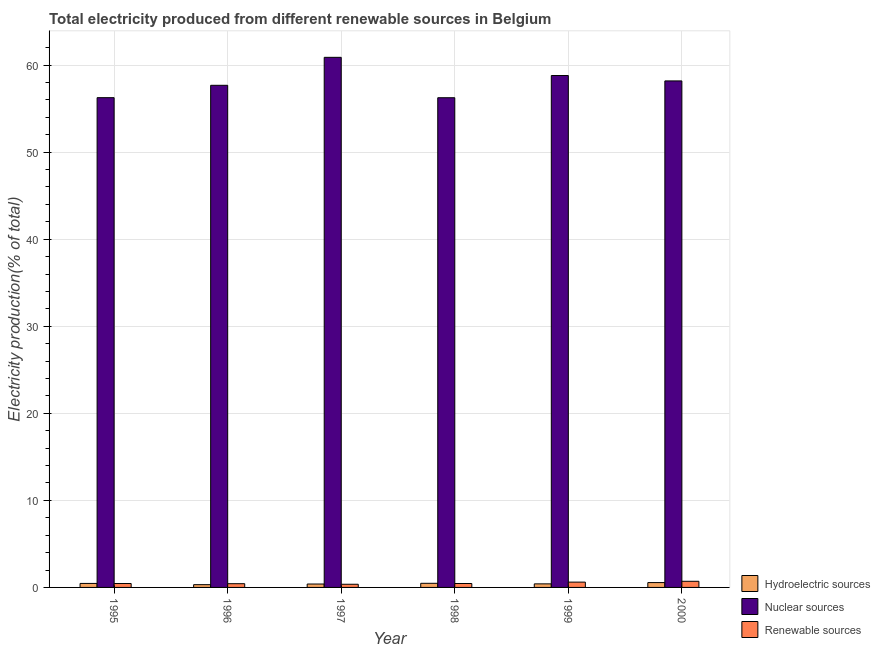How many bars are there on the 4th tick from the left?
Keep it short and to the point. 3. How many bars are there on the 4th tick from the right?
Make the answer very short. 3. In how many cases, is the number of bars for a given year not equal to the number of legend labels?
Provide a short and direct response. 0. What is the percentage of electricity produced by renewable sources in 1997?
Your answer should be very brief. 0.36. Across all years, what is the maximum percentage of electricity produced by hydroelectric sources?
Make the answer very short. 0.56. Across all years, what is the minimum percentage of electricity produced by renewable sources?
Provide a short and direct response. 0.36. In which year was the percentage of electricity produced by nuclear sources maximum?
Make the answer very short. 1997. What is the total percentage of electricity produced by hydroelectric sources in the graph?
Your answer should be very brief. 2.61. What is the difference between the percentage of electricity produced by nuclear sources in 1998 and that in 1999?
Make the answer very short. -2.55. What is the difference between the percentage of electricity produced by nuclear sources in 1997 and the percentage of electricity produced by hydroelectric sources in 1995?
Make the answer very short. 4.63. What is the average percentage of electricity produced by nuclear sources per year?
Give a very brief answer. 58.01. In the year 1997, what is the difference between the percentage of electricity produced by nuclear sources and percentage of electricity produced by hydroelectric sources?
Make the answer very short. 0. What is the ratio of the percentage of electricity produced by renewable sources in 1995 to that in 1999?
Offer a terse response. 0.74. Is the percentage of electricity produced by hydroelectric sources in 1996 less than that in 1997?
Make the answer very short. Yes. What is the difference between the highest and the second highest percentage of electricity produced by nuclear sources?
Provide a short and direct response. 2.09. What is the difference between the highest and the lowest percentage of electricity produced by hydroelectric sources?
Your answer should be very brief. 0.24. Is the sum of the percentage of electricity produced by renewable sources in 1995 and 1997 greater than the maximum percentage of electricity produced by nuclear sources across all years?
Ensure brevity in your answer.  Yes. What does the 3rd bar from the left in 1998 represents?
Offer a terse response. Renewable sources. What does the 2nd bar from the right in 2000 represents?
Your response must be concise. Nuclear sources. Is it the case that in every year, the sum of the percentage of electricity produced by hydroelectric sources and percentage of electricity produced by nuclear sources is greater than the percentage of electricity produced by renewable sources?
Make the answer very short. Yes. How many bars are there?
Offer a very short reply. 18. Are the values on the major ticks of Y-axis written in scientific E-notation?
Offer a terse response. No. Does the graph contain any zero values?
Your response must be concise. No. Does the graph contain grids?
Provide a succinct answer. Yes. Where does the legend appear in the graph?
Offer a terse response. Bottom right. How many legend labels are there?
Keep it short and to the point. 3. What is the title of the graph?
Give a very brief answer. Total electricity produced from different renewable sources in Belgium. Does "Renewable sources" appear as one of the legend labels in the graph?
Your answer should be very brief. Yes. What is the label or title of the X-axis?
Make the answer very short. Year. What is the label or title of the Y-axis?
Your response must be concise. Electricity production(% of total). What is the Electricity production(% of total) in Hydroelectric sources in 1995?
Provide a succinct answer. 0.46. What is the Electricity production(% of total) in Nuclear sources in 1995?
Offer a terse response. 56.25. What is the Electricity production(% of total) of Renewable sources in 1995?
Offer a very short reply. 0.45. What is the Electricity production(% of total) of Hydroelectric sources in 1996?
Offer a very short reply. 0.32. What is the Electricity production(% of total) of Nuclear sources in 1996?
Ensure brevity in your answer.  57.68. What is the Electricity production(% of total) of Renewable sources in 1996?
Provide a succinct answer. 0.43. What is the Electricity production(% of total) of Hydroelectric sources in 1997?
Provide a short and direct response. 0.39. What is the Electricity production(% of total) of Nuclear sources in 1997?
Give a very brief answer. 60.89. What is the Electricity production(% of total) of Renewable sources in 1997?
Provide a succinct answer. 0.36. What is the Electricity production(% of total) in Hydroelectric sources in 1998?
Keep it short and to the point. 0.47. What is the Electricity production(% of total) of Nuclear sources in 1998?
Provide a short and direct response. 56.25. What is the Electricity production(% of total) in Renewable sources in 1998?
Give a very brief answer. 0.45. What is the Electricity production(% of total) in Hydroelectric sources in 1999?
Your answer should be very brief. 0.41. What is the Electricity production(% of total) in Nuclear sources in 1999?
Your answer should be compact. 58.8. What is the Electricity production(% of total) of Renewable sources in 1999?
Offer a terse response. 0.61. What is the Electricity production(% of total) in Hydroelectric sources in 2000?
Give a very brief answer. 0.56. What is the Electricity production(% of total) in Nuclear sources in 2000?
Your response must be concise. 58.18. What is the Electricity production(% of total) of Renewable sources in 2000?
Offer a very short reply. 0.71. Across all years, what is the maximum Electricity production(% of total) of Hydroelectric sources?
Keep it short and to the point. 0.56. Across all years, what is the maximum Electricity production(% of total) of Nuclear sources?
Your response must be concise. 60.89. Across all years, what is the maximum Electricity production(% of total) in Renewable sources?
Make the answer very short. 0.71. Across all years, what is the minimum Electricity production(% of total) of Hydroelectric sources?
Provide a succinct answer. 0.32. Across all years, what is the minimum Electricity production(% of total) of Nuclear sources?
Provide a succinct answer. 56.25. Across all years, what is the minimum Electricity production(% of total) in Renewable sources?
Keep it short and to the point. 0.36. What is the total Electricity production(% of total) in Hydroelectric sources in the graph?
Offer a terse response. 2.61. What is the total Electricity production(% of total) in Nuclear sources in the graph?
Keep it short and to the point. 348.04. What is the total Electricity production(% of total) in Renewable sources in the graph?
Your answer should be very brief. 3.01. What is the difference between the Electricity production(% of total) in Hydroelectric sources in 1995 and that in 1996?
Your answer should be very brief. 0.14. What is the difference between the Electricity production(% of total) in Nuclear sources in 1995 and that in 1996?
Make the answer very short. -1.42. What is the difference between the Electricity production(% of total) in Renewable sources in 1995 and that in 1996?
Ensure brevity in your answer.  0.02. What is the difference between the Electricity production(% of total) in Hydroelectric sources in 1995 and that in 1997?
Provide a succinct answer. 0.07. What is the difference between the Electricity production(% of total) of Nuclear sources in 1995 and that in 1997?
Your answer should be very brief. -4.63. What is the difference between the Electricity production(% of total) in Renewable sources in 1995 and that in 1997?
Your answer should be very brief. 0.09. What is the difference between the Electricity production(% of total) of Hydroelectric sources in 1995 and that in 1998?
Offer a very short reply. -0.01. What is the difference between the Electricity production(% of total) of Nuclear sources in 1995 and that in 1998?
Make the answer very short. 0.01. What is the difference between the Electricity production(% of total) of Renewable sources in 1995 and that in 1998?
Give a very brief answer. -0. What is the difference between the Electricity production(% of total) of Hydroelectric sources in 1995 and that in 1999?
Offer a terse response. 0.05. What is the difference between the Electricity production(% of total) of Nuclear sources in 1995 and that in 1999?
Give a very brief answer. -2.54. What is the difference between the Electricity production(% of total) of Renewable sources in 1995 and that in 1999?
Provide a short and direct response. -0.16. What is the difference between the Electricity production(% of total) in Hydroelectric sources in 1995 and that in 2000?
Give a very brief answer. -0.1. What is the difference between the Electricity production(% of total) of Nuclear sources in 1995 and that in 2000?
Offer a terse response. -1.93. What is the difference between the Electricity production(% of total) in Renewable sources in 1995 and that in 2000?
Provide a succinct answer. -0.26. What is the difference between the Electricity production(% of total) of Hydroelectric sources in 1996 and that in 1997?
Offer a very short reply. -0.07. What is the difference between the Electricity production(% of total) of Nuclear sources in 1996 and that in 1997?
Make the answer very short. -3.21. What is the difference between the Electricity production(% of total) of Renewable sources in 1996 and that in 1997?
Give a very brief answer. 0.07. What is the difference between the Electricity production(% of total) of Hydroelectric sources in 1996 and that in 1998?
Your response must be concise. -0.16. What is the difference between the Electricity production(% of total) of Nuclear sources in 1996 and that in 1998?
Offer a very short reply. 1.43. What is the difference between the Electricity production(% of total) of Renewable sources in 1996 and that in 1998?
Your answer should be very brief. -0.02. What is the difference between the Electricity production(% of total) in Hydroelectric sources in 1996 and that in 1999?
Offer a very short reply. -0.09. What is the difference between the Electricity production(% of total) of Nuclear sources in 1996 and that in 1999?
Your answer should be compact. -1.12. What is the difference between the Electricity production(% of total) in Renewable sources in 1996 and that in 1999?
Keep it short and to the point. -0.18. What is the difference between the Electricity production(% of total) in Hydroelectric sources in 1996 and that in 2000?
Your answer should be compact. -0.24. What is the difference between the Electricity production(% of total) in Nuclear sources in 1996 and that in 2000?
Ensure brevity in your answer.  -0.5. What is the difference between the Electricity production(% of total) in Renewable sources in 1996 and that in 2000?
Provide a succinct answer. -0.28. What is the difference between the Electricity production(% of total) of Hydroelectric sources in 1997 and that in 1998?
Provide a short and direct response. -0.08. What is the difference between the Electricity production(% of total) of Nuclear sources in 1997 and that in 1998?
Offer a very short reply. 4.64. What is the difference between the Electricity production(% of total) of Renewable sources in 1997 and that in 1998?
Offer a very short reply. -0.09. What is the difference between the Electricity production(% of total) of Hydroelectric sources in 1997 and that in 1999?
Offer a very short reply. -0.02. What is the difference between the Electricity production(% of total) of Nuclear sources in 1997 and that in 1999?
Your response must be concise. 2.09. What is the difference between the Electricity production(% of total) of Renewable sources in 1997 and that in 1999?
Provide a succinct answer. -0.25. What is the difference between the Electricity production(% of total) of Hydroelectric sources in 1997 and that in 2000?
Offer a very short reply. -0.16. What is the difference between the Electricity production(% of total) in Nuclear sources in 1997 and that in 2000?
Ensure brevity in your answer.  2.71. What is the difference between the Electricity production(% of total) in Renewable sources in 1997 and that in 2000?
Your answer should be compact. -0.34. What is the difference between the Electricity production(% of total) in Hydroelectric sources in 1998 and that in 1999?
Provide a short and direct response. 0.06. What is the difference between the Electricity production(% of total) in Nuclear sources in 1998 and that in 1999?
Provide a short and direct response. -2.55. What is the difference between the Electricity production(% of total) in Renewable sources in 1998 and that in 1999?
Ensure brevity in your answer.  -0.16. What is the difference between the Electricity production(% of total) of Hydroelectric sources in 1998 and that in 2000?
Your answer should be very brief. -0.08. What is the difference between the Electricity production(% of total) of Nuclear sources in 1998 and that in 2000?
Your response must be concise. -1.93. What is the difference between the Electricity production(% of total) in Renewable sources in 1998 and that in 2000?
Provide a succinct answer. -0.25. What is the difference between the Electricity production(% of total) in Hydroelectric sources in 1999 and that in 2000?
Your answer should be very brief. -0.15. What is the difference between the Electricity production(% of total) of Nuclear sources in 1999 and that in 2000?
Offer a terse response. 0.62. What is the difference between the Electricity production(% of total) in Renewable sources in 1999 and that in 2000?
Provide a succinct answer. -0.1. What is the difference between the Electricity production(% of total) in Hydroelectric sources in 1995 and the Electricity production(% of total) in Nuclear sources in 1996?
Offer a terse response. -57.22. What is the difference between the Electricity production(% of total) of Hydroelectric sources in 1995 and the Electricity production(% of total) of Renewable sources in 1996?
Your response must be concise. 0.03. What is the difference between the Electricity production(% of total) in Nuclear sources in 1995 and the Electricity production(% of total) in Renewable sources in 1996?
Make the answer very short. 55.83. What is the difference between the Electricity production(% of total) of Hydroelectric sources in 1995 and the Electricity production(% of total) of Nuclear sources in 1997?
Provide a succinct answer. -60.43. What is the difference between the Electricity production(% of total) of Hydroelectric sources in 1995 and the Electricity production(% of total) of Renewable sources in 1997?
Give a very brief answer. 0.1. What is the difference between the Electricity production(% of total) of Nuclear sources in 1995 and the Electricity production(% of total) of Renewable sources in 1997?
Offer a terse response. 55.89. What is the difference between the Electricity production(% of total) of Hydroelectric sources in 1995 and the Electricity production(% of total) of Nuclear sources in 1998?
Your answer should be very brief. -55.79. What is the difference between the Electricity production(% of total) of Hydroelectric sources in 1995 and the Electricity production(% of total) of Renewable sources in 1998?
Provide a short and direct response. 0.01. What is the difference between the Electricity production(% of total) of Nuclear sources in 1995 and the Electricity production(% of total) of Renewable sources in 1998?
Keep it short and to the point. 55.8. What is the difference between the Electricity production(% of total) of Hydroelectric sources in 1995 and the Electricity production(% of total) of Nuclear sources in 1999?
Your response must be concise. -58.34. What is the difference between the Electricity production(% of total) of Hydroelectric sources in 1995 and the Electricity production(% of total) of Renewable sources in 1999?
Your response must be concise. -0.15. What is the difference between the Electricity production(% of total) in Nuclear sources in 1995 and the Electricity production(% of total) in Renewable sources in 1999?
Ensure brevity in your answer.  55.64. What is the difference between the Electricity production(% of total) in Hydroelectric sources in 1995 and the Electricity production(% of total) in Nuclear sources in 2000?
Your answer should be very brief. -57.72. What is the difference between the Electricity production(% of total) of Hydroelectric sources in 1995 and the Electricity production(% of total) of Renewable sources in 2000?
Give a very brief answer. -0.25. What is the difference between the Electricity production(% of total) of Nuclear sources in 1995 and the Electricity production(% of total) of Renewable sources in 2000?
Offer a very short reply. 55.55. What is the difference between the Electricity production(% of total) in Hydroelectric sources in 1996 and the Electricity production(% of total) in Nuclear sources in 1997?
Give a very brief answer. -60.57. What is the difference between the Electricity production(% of total) of Hydroelectric sources in 1996 and the Electricity production(% of total) of Renewable sources in 1997?
Your response must be concise. -0.05. What is the difference between the Electricity production(% of total) in Nuclear sources in 1996 and the Electricity production(% of total) in Renewable sources in 1997?
Your answer should be very brief. 57.31. What is the difference between the Electricity production(% of total) of Hydroelectric sources in 1996 and the Electricity production(% of total) of Nuclear sources in 1998?
Your answer should be compact. -55.93. What is the difference between the Electricity production(% of total) in Hydroelectric sources in 1996 and the Electricity production(% of total) in Renewable sources in 1998?
Make the answer very short. -0.13. What is the difference between the Electricity production(% of total) in Nuclear sources in 1996 and the Electricity production(% of total) in Renewable sources in 1998?
Your response must be concise. 57.22. What is the difference between the Electricity production(% of total) in Hydroelectric sources in 1996 and the Electricity production(% of total) in Nuclear sources in 1999?
Your response must be concise. -58.48. What is the difference between the Electricity production(% of total) in Hydroelectric sources in 1996 and the Electricity production(% of total) in Renewable sources in 1999?
Provide a succinct answer. -0.29. What is the difference between the Electricity production(% of total) in Nuclear sources in 1996 and the Electricity production(% of total) in Renewable sources in 1999?
Give a very brief answer. 57.06. What is the difference between the Electricity production(% of total) of Hydroelectric sources in 1996 and the Electricity production(% of total) of Nuclear sources in 2000?
Your answer should be compact. -57.86. What is the difference between the Electricity production(% of total) in Hydroelectric sources in 1996 and the Electricity production(% of total) in Renewable sources in 2000?
Offer a terse response. -0.39. What is the difference between the Electricity production(% of total) in Nuclear sources in 1996 and the Electricity production(% of total) in Renewable sources in 2000?
Provide a succinct answer. 56.97. What is the difference between the Electricity production(% of total) in Hydroelectric sources in 1997 and the Electricity production(% of total) in Nuclear sources in 1998?
Your answer should be compact. -55.86. What is the difference between the Electricity production(% of total) in Hydroelectric sources in 1997 and the Electricity production(% of total) in Renewable sources in 1998?
Provide a short and direct response. -0.06. What is the difference between the Electricity production(% of total) of Nuclear sources in 1997 and the Electricity production(% of total) of Renewable sources in 1998?
Make the answer very short. 60.44. What is the difference between the Electricity production(% of total) in Hydroelectric sources in 1997 and the Electricity production(% of total) in Nuclear sources in 1999?
Make the answer very short. -58.41. What is the difference between the Electricity production(% of total) in Hydroelectric sources in 1997 and the Electricity production(% of total) in Renewable sources in 1999?
Offer a terse response. -0.22. What is the difference between the Electricity production(% of total) in Nuclear sources in 1997 and the Electricity production(% of total) in Renewable sources in 1999?
Your answer should be very brief. 60.28. What is the difference between the Electricity production(% of total) in Hydroelectric sources in 1997 and the Electricity production(% of total) in Nuclear sources in 2000?
Offer a terse response. -57.79. What is the difference between the Electricity production(% of total) of Hydroelectric sources in 1997 and the Electricity production(% of total) of Renewable sources in 2000?
Offer a very short reply. -0.31. What is the difference between the Electricity production(% of total) in Nuclear sources in 1997 and the Electricity production(% of total) in Renewable sources in 2000?
Provide a short and direct response. 60.18. What is the difference between the Electricity production(% of total) in Hydroelectric sources in 1998 and the Electricity production(% of total) in Nuclear sources in 1999?
Your answer should be very brief. -58.32. What is the difference between the Electricity production(% of total) in Hydroelectric sources in 1998 and the Electricity production(% of total) in Renewable sources in 1999?
Make the answer very short. -0.14. What is the difference between the Electricity production(% of total) of Nuclear sources in 1998 and the Electricity production(% of total) of Renewable sources in 1999?
Offer a terse response. 55.64. What is the difference between the Electricity production(% of total) in Hydroelectric sources in 1998 and the Electricity production(% of total) in Nuclear sources in 2000?
Your answer should be very brief. -57.71. What is the difference between the Electricity production(% of total) in Hydroelectric sources in 1998 and the Electricity production(% of total) in Renewable sources in 2000?
Keep it short and to the point. -0.23. What is the difference between the Electricity production(% of total) of Nuclear sources in 1998 and the Electricity production(% of total) of Renewable sources in 2000?
Your response must be concise. 55.54. What is the difference between the Electricity production(% of total) in Hydroelectric sources in 1999 and the Electricity production(% of total) in Nuclear sources in 2000?
Keep it short and to the point. -57.77. What is the difference between the Electricity production(% of total) in Hydroelectric sources in 1999 and the Electricity production(% of total) in Renewable sources in 2000?
Offer a very short reply. -0.3. What is the difference between the Electricity production(% of total) of Nuclear sources in 1999 and the Electricity production(% of total) of Renewable sources in 2000?
Ensure brevity in your answer.  58.09. What is the average Electricity production(% of total) in Hydroelectric sources per year?
Your answer should be compact. 0.43. What is the average Electricity production(% of total) of Nuclear sources per year?
Keep it short and to the point. 58.01. What is the average Electricity production(% of total) in Renewable sources per year?
Offer a very short reply. 0.5. In the year 1995, what is the difference between the Electricity production(% of total) in Hydroelectric sources and Electricity production(% of total) in Nuclear sources?
Ensure brevity in your answer.  -55.79. In the year 1995, what is the difference between the Electricity production(% of total) in Hydroelectric sources and Electricity production(% of total) in Renewable sources?
Your answer should be very brief. 0.01. In the year 1995, what is the difference between the Electricity production(% of total) in Nuclear sources and Electricity production(% of total) in Renewable sources?
Offer a terse response. 55.81. In the year 1996, what is the difference between the Electricity production(% of total) of Hydroelectric sources and Electricity production(% of total) of Nuclear sources?
Keep it short and to the point. -57.36. In the year 1996, what is the difference between the Electricity production(% of total) in Hydroelectric sources and Electricity production(% of total) in Renewable sources?
Offer a terse response. -0.11. In the year 1996, what is the difference between the Electricity production(% of total) in Nuclear sources and Electricity production(% of total) in Renewable sources?
Your answer should be very brief. 57.25. In the year 1997, what is the difference between the Electricity production(% of total) of Hydroelectric sources and Electricity production(% of total) of Nuclear sources?
Ensure brevity in your answer.  -60.5. In the year 1997, what is the difference between the Electricity production(% of total) of Hydroelectric sources and Electricity production(% of total) of Renewable sources?
Make the answer very short. 0.03. In the year 1997, what is the difference between the Electricity production(% of total) in Nuclear sources and Electricity production(% of total) in Renewable sources?
Provide a short and direct response. 60.52. In the year 1998, what is the difference between the Electricity production(% of total) in Hydroelectric sources and Electricity production(% of total) in Nuclear sources?
Provide a short and direct response. -55.77. In the year 1998, what is the difference between the Electricity production(% of total) in Hydroelectric sources and Electricity production(% of total) in Renewable sources?
Offer a terse response. 0.02. In the year 1998, what is the difference between the Electricity production(% of total) of Nuclear sources and Electricity production(% of total) of Renewable sources?
Offer a terse response. 55.8. In the year 1999, what is the difference between the Electricity production(% of total) of Hydroelectric sources and Electricity production(% of total) of Nuclear sources?
Your response must be concise. -58.39. In the year 1999, what is the difference between the Electricity production(% of total) in Hydroelectric sources and Electricity production(% of total) in Renewable sources?
Keep it short and to the point. -0.2. In the year 1999, what is the difference between the Electricity production(% of total) in Nuclear sources and Electricity production(% of total) in Renewable sources?
Your response must be concise. 58.19. In the year 2000, what is the difference between the Electricity production(% of total) in Hydroelectric sources and Electricity production(% of total) in Nuclear sources?
Provide a succinct answer. -57.62. In the year 2000, what is the difference between the Electricity production(% of total) in Hydroelectric sources and Electricity production(% of total) in Renewable sources?
Provide a short and direct response. -0.15. In the year 2000, what is the difference between the Electricity production(% of total) of Nuclear sources and Electricity production(% of total) of Renewable sources?
Provide a short and direct response. 57.47. What is the ratio of the Electricity production(% of total) in Hydroelectric sources in 1995 to that in 1996?
Offer a very short reply. 1.45. What is the ratio of the Electricity production(% of total) of Nuclear sources in 1995 to that in 1996?
Ensure brevity in your answer.  0.98. What is the ratio of the Electricity production(% of total) in Renewable sources in 1995 to that in 1996?
Provide a short and direct response. 1.05. What is the ratio of the Electricity production(% of total) of Hydroelectric sources in 1995 to that in 1997?
Keep it short and to the point. 1.17. What is the ratio of the Electricity production(% of total) of Nuclear sources in 1995 to that in 1997?
Make the answer very short. 0.92. What is the ratio of the Electricity production(% of total) in Renewable sources in 1995 to that in 1997?
Offer a terse response. 1.24. What is the ratio of the Electricity production(% of total) of Hydroelectric sources in 1995 to that in 1998?
Offer a terse response. 0.97. What is the ratio of the Electricity production(% of total) in Nuclear sources in 1995 to that in 1998?
Provide a succinct answer. 1. What is the ratio of the Electricity production(% of total) in Renewable sources in 1995 to that in 1998?
Your answer should be very brief. 1. What is the ratio of the Electricity production(% of total) in Hydroelectric sources in 1995 to that in 1999?
Make the answer very short. 1.12. What is the ratio of the Electricity production(% of total) in Nuclear sources in 1995 to that in 1999?
Ensure brevity in your answer.  0.96. What is the ratio of the Electricity production(% of total) of Renewable sources in 1995 to that in 1999?
Offer a terse response. 0.74. What is the ratio of the Electricity production(% of total) of Hydroelectric sources in 1995 to that in 2000?
Make the answer very short. 0.83. What is the ratio of the Electricity production(% of total) of Nuclear sources in 1995 to that in 2000?
Your answer should be compact. 0.97. What is the ratio of the Electricity production(% of total) of Renewable sources in 1995 to that in 2000?
Offer a terse response. 0.64. What is the ratio of the Electricity production(% of total) in Hydroelectric sources in 1996 to that in 1997?
Offer a very short reply. 0.81. What is the ratio of the Electricity production(% of total) in Nuclear sources in 1996 to that in 1997?
Keep it short and to the point. 0.95. What is the ratio of the Electricity production(% of total) of Renewable sources in 1996 to that in 1997?
Keep it short and to the point. 1.18. What is the ratio of the Electricity production(% of total) in Hydroelectric sources in 1996 to that in 1998?
Offer a very short reply. 0.67. What is the ratio of the Electricity production(% of total) of Nuclear sources in 1996 to that in 1998?
Your response must be concise. 1.03. What is the ratio of the Electricity production(% of total) of Renewable sources in 1996 to that in 1998?
Offer a terse response. 0.95. What is the ratio of the Electricity production(% of total) in Hydroelectric sources in 1996 to that in 1999?
Your response must be concise. 0.78. What is the ratio of the Electricity production(% of total) in Nuclear sources in 1996 to that in 1999?
Provide a short and direct response. 0.98. What is the ratio of the Electricity production(% of total) of Renewable sources in 1996 to that in 1999?
Offer a terse response. 0.7. What is the ratio of the Electricity production(% of total) in Hydroelectric sources in 1996 to that in 2000?
Keep it short and to the point. 0.57. What is the ratio of the Electricity production(% of total) in Nuclear sources in 1996 to that in 2000?
Provide a succinct answer. 0.99. What is the ratio of the Electricity production(% of total) of Renewable sources in 1996 to that in 2000?
Keep it short and to the point. 0.61. What is the ratio of the Electricity production(% of total) in Hydroelectric sources in 1997 to that in 1998?
Your response must be concise. 0.83. What is the ratio of the Electricity production(% of total) of Nuclear sources in 1997 to that in 1998?
Keep it short and to the point. 1.08. What is the ratio of the Electricity production(% of total) of Renewable sources in 1997 to that in 1998?
Offer a very short reply. 0.81. What is the ratio of the Electricity production(% of total) of Hydroelectric sources in 1997 to that in 1999?
Keep it short and to the point. 0.96. What is the ratio of the Electricity production(% of total) of Nuclear sources in 1997 to that in 1999?
Keep it short and to the point. 1.04. What is the ratio of the Electricity production(% of total) in Renewable sources in 1997 to that in 1999?
Provide a succinct answer. 0.6. What is the ratio of the Electricity production(% of total) in Hydroelectric sources in 1997 to that in 2000?
Provide a short and direct response. 0.7. What is the ratio of the Electricity production(% of total) in Nuclear sources in 1997 to that in 2000?
Offer a terse response. 1.05. What is the ratio of the Electricity production(% of total) in Renewable sources in 1997 to that in 2000?
Provide a succinct answer. 0.52. What is the ratio of the Electricity production(% of total) of Hydroelectric sources in 1998 to that in 1999?
Give a very brief answer. 1.16. What is the ratio of the Electricity production(% of total) of Nuclear sources in 1998 to that in 1999?
Offer a terse response. 0.96. What is the ratio of the Electricity production(% of total) in Renewable sources in 1998 to that in 1999?
Make the answer very short. 0.74. What is the ratio of the Electricity production(% of total) of Hydroelectric sources in 1998 to that in 2000?
Your answer should be compact. 0.85. What is the ratio of the Electricity production(% of total) in Nuclear sources in 1998 to that in 2000?
Provide a short and direct response. 0.97. What is the ratio of the Electricity production(% of total) in Renewable sources in 1998 to that in 2000?
Provide a succinct answer. 0.64. What is the ratio of the Electricity production(% of total) in Hydroelectric sources in 1999 to that in 2000?
Provide a short and direct response. 0.74. What is the ratio of the Electricity production(% of total) in Nuclear sources in 1999 to that in 2000?
Provide a succinct answer. 1.01. What is the ratio of the Electricity production(% of total) of Renewable sources in 1999 to that in 2000?
Provide a short and direct response. 0.87. What is the difference between the highest and the second highest Electricity production(% of total) of Hydroelectric sources?
Provide a succinct answer. 0.08. What is the difference between the highest and the second highest Electricity production(% of total) in Nuclear sources?
Your response must be concise. 2.09. What is the difference between the highest and the second highest Electricity production(% of total) in Renewable sources?
Your answer should be very brief. 0.1. What is the difference between the highest and the lowest Electricity production(% of total) in Hydroelectric sources?
Offer a terse response. 0.24. What is the difference between the highest and the lowest Electricity production(% of total) in Nuclear sources?
Give a very brief answer. 4.64. What is the difference between the highest and the lowest Electricity production(% of total) in Renewable sources?
Make the answer very short. 0.34. 